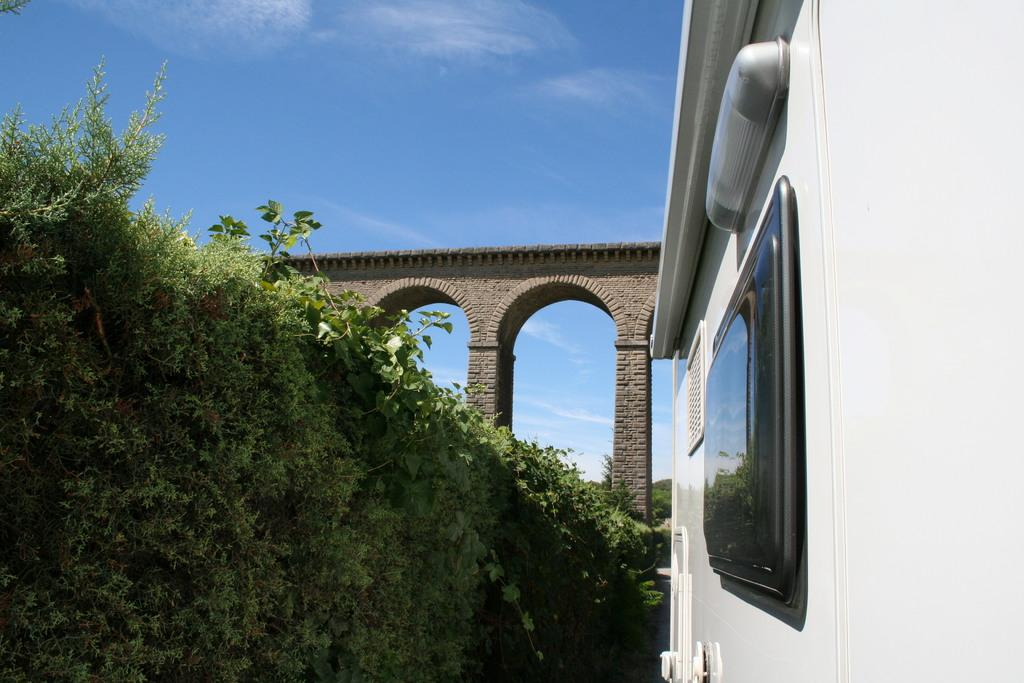What can be seen in the front of the image? There are trees, a white wall, a light, and a window in the front of the image. What is located in the background of the image? There are mountains, a bridge, and a blue sky in the background of the image. What type of structure is visible in the background? There is a bridge in the background of the image. What color is the sky in the background of the image? The sky is blue in the background of the image. Where is the ship docked in the image? There is no ship present in the image. What type of test is being conducted in the image? There is no test being conducted in the image. 